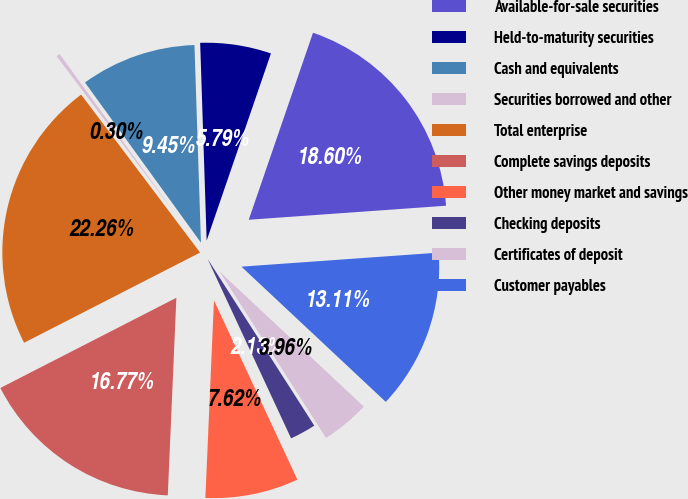Convert chart to OTSL. <chart><loc_0><loc_0><loc_500><loc_500><pie_chart><fcel>Available-for-sale securities<fcel>Held-to-maturity securities<fcel>Cash and equivalents<fcel>Securities borrowed and other<fcel>Total enterprise<fcel>Complete savings deposits<fcel>Other money market and savings<fcel>Checking deposits<fcel>Certificates of deposit<fcel>Customer payables<nl><fcel>18.6%<fcel>5.79%<fcel>9.45%<fcel>0.3%<fcel>22.26%<fcel>16.77%<fcel>7.62%<fcel>2.13%<fcel>3.96%<fcel>13.11%<nl></chart> 